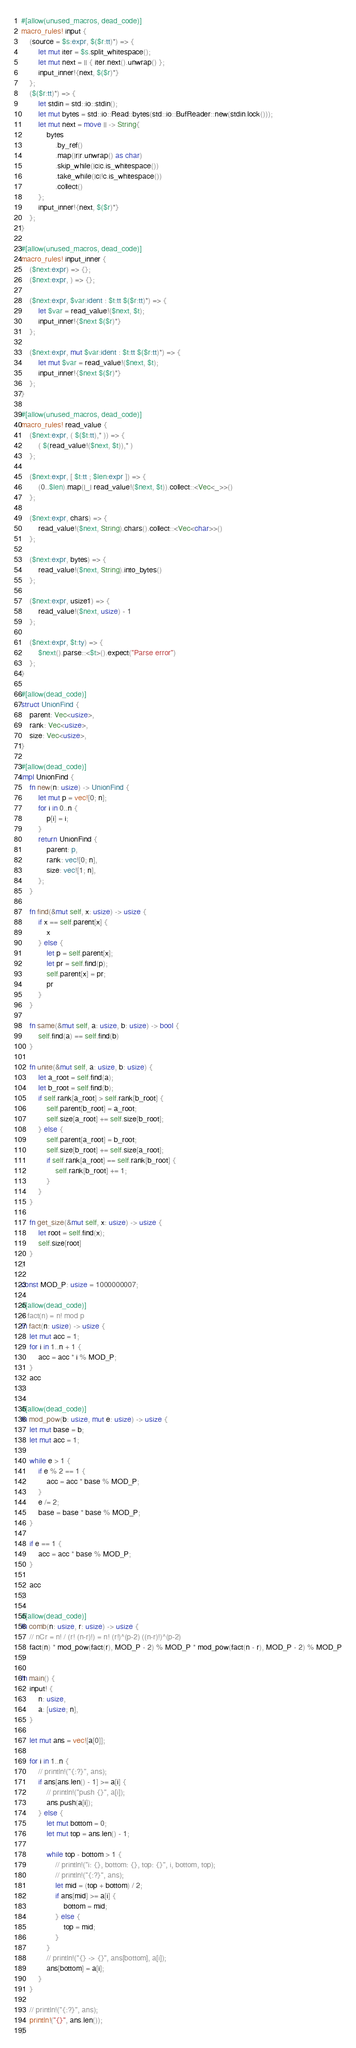Convert code to text. <code><loc_0><loc_0><loc_500><loc_500><_Rust_>#[allow(unused_macros, dead_code)]
macro_rules! input {
    (source = $s:expr, $($r:tt)*) => {
        let mut iter = $s.split_whitespace();
        let mut next = || { iter.next().unwrap() };
        input_inner!{next, $($r)*}
    };
    ($($r:tt)*) => {
        let stdin = std::io::stdin();
        let mut bytes = std::io::Read::bytes(std::io::BufReader::new(stdin.lock()));
        let mut next = move || -> String{
            bytes
                .by_ref()
                .map(|r|r.unwrap() as char)
                .skip_while(|c|c.is_whitespace())
                .take_while(|c|!c.is_whitespace())
                .collect()
        };
        input_inner!{next, $($r)*}
    };
}

#[allow(unused_macros, dead_code)]
macro_rules! input_inner {
    ($next:expr) => {};
    ($next:expr, ) => {};

    ($next:expr, $var:ident : $t:tt $($r:tt)*) => {
        let $var = read_value!($next, $t);
        input_inner!{$next $($r)*}
    };

    ($next:expr, mut $var:ident : $t:tt $($r:tt)*) => {
        let mut $var = read_value!($next, $t);
        input_inner!{$next $($r)*}
    };
}

#[allow(unused_macros, dead_code)]
macro_rules! read_value {
    ($next:expr, ( $($t:tt),* )) => {
        ( $(read_value!($next, $t)),* )
    };

    ($next:expr, [ $t:tt ; $len:expr ]) => {
        (0..$len).map(|_| read_value!($next, $t)).collect::<Vec<_>>()
    };

    ($next:expr, chars) => {
        read_value!($next, String).chars().collect::<Vec<char>>()
    };

    ($next:expr, bytes) => {
        read_value!($next, String).into_bytes()
    };

    ($next:expr, usize1) => {
        read_value!($next, usize) - 1
    };

    ($next:expr, $t:ty) => {
        $next().parse::<$t>().expect("Parse error")
    };
}

#[allow(dead_code)]
struct UnionFind {
    parent: Vec<usize>,
    rank: Vec<usize>,
    size: Vec<usize>,
}

#[allow(dead_code)]
impl UnionFind {
    fn new(n: usize) -> UnionFind {
        let mut p = vec![0; n];
        for i in 0..n {
            p[i] = i;
        }
        return UnionFind {
            parent: p,
            rank: vec![0; n],
            size: vec![1; n],
        };
    }

    fn find(&mut self, x: usize) -> usize {
        if x == self.parent[x] {
            x
        } else {
            let p = self.parent[x];
            let pr = self.find(p);
            self.parent[x] = pr;
            pr
        }
    }

    fn same(&mut self, a: usize, b: usize) -> bool {
        self.find(a) == self.find(b)
    }

    fn unite(&mut self, a: usize, b: usize) {
        let a_root = self.find(a);
        let b_root = self.find(b);
        if self.rank[a_root] > self.rank[b_root] {
            self.parent[b_root] = a_root;
            self.size[a_root] += self.size[b_root];
        } else {
            self.parent[a_root] = b_root;
            self.size[b_root] += self.size[a_root];
            if self.rank[a_root] == self.rank[b_root] {
                self.rank[b_root] += 1;
            }
        }
    }

    fn get_size(&mut self, x: usize) -> usize {
        let root = self.find(x);
        self.size[root]
    }
}

const MOD_P: usize = 1000000007;

#[allow(dead_code)]
// fact(n) = n! mod p
fn fact(n: usize) -> usize {
    let mut acc = 1;
    for i in 1..n + 1 {
        acc = acc * i % MOD_P;
    }
    acc
}

#[allow(dead_code)]
fn mod_pow(b: usize, mut e: usize) -> usize {
    let mut base = b;
    let mut acc = 1;

    while e > 1 {
        if e % 2 == 1 {
            acc = acc * base % MOD_P;
        }
        e /= 2;
        base = base * base % MOD_P;
    }

    if e == 1 {
        acc = acc * base % MOD_P;
    }

    acc
}

#[allow(dead_code)]
fn comb(n: usize, r: usize) -> usize {
    // nCr = n! / (r! (n-r)!) = n! (r!)^(p-2) ((n-r)!)^(p-2)
    fact(n) * mod_pow(fact(r), MOD_P - 2) % MOD_P * mod_pow(fact(n - r), MOD_P - 2) % MOD_P
}

fn main() {
    input! {
        n: usize,
        a: [usize; n],
    }

    let mut ans = vec![a[0]];

    for i in 1..n {
        // println!("{:?}", ans);
        if ans[ans.len() - 1] >= a[i] {
            // println!("push {}", a[i]);
            ans.push(a[i]);
        } else {
            let mut bottom = 0;
            let mut top = ans.len() - 1;

            while top - bottom > 1 {
                // println!("i: {}, bottom: {}, top: {}", i, bottom, top);
                // println!("{:?}", ans);
                let mid = (top + bottom) / 2;
                if ans[mid] >= a[i] {
                    bottom = mid;
                } else {
                    top = mid;
                }
            }
            // println!("{} -> {}", ans[bottom], a[i]);
            ans[bottom] = a[i];
        }
    }

    // println!("{:?}", ans);
    println!("{}", ans.len());
}
</code> 